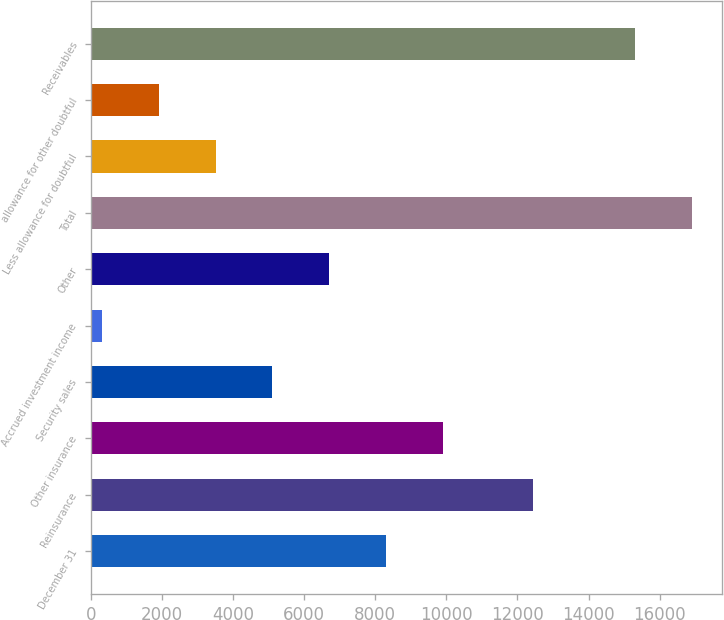Convert chart. <chart><loc_0><loc_0><loc_500><loc_500><bar_chart><fcel>December 31<fcel>Reinsurance<fcel>Other insurance<fcel>Security sales<fcel>Accrued investment income<fcel>Other<fcel>Total<fcel>Less allowance for doubtful<fcel>allowance for other doubtful<fcel>Receivables<nl><fcel>8304.6<fcel>12436.7<fcel>9901.08<fcel>5111.64<fcel>322.2<fcel>6708.12<fcel>16910.2<fcel>3515.16<fcel>1918.68<fcel>15313.7<nl></chart> 